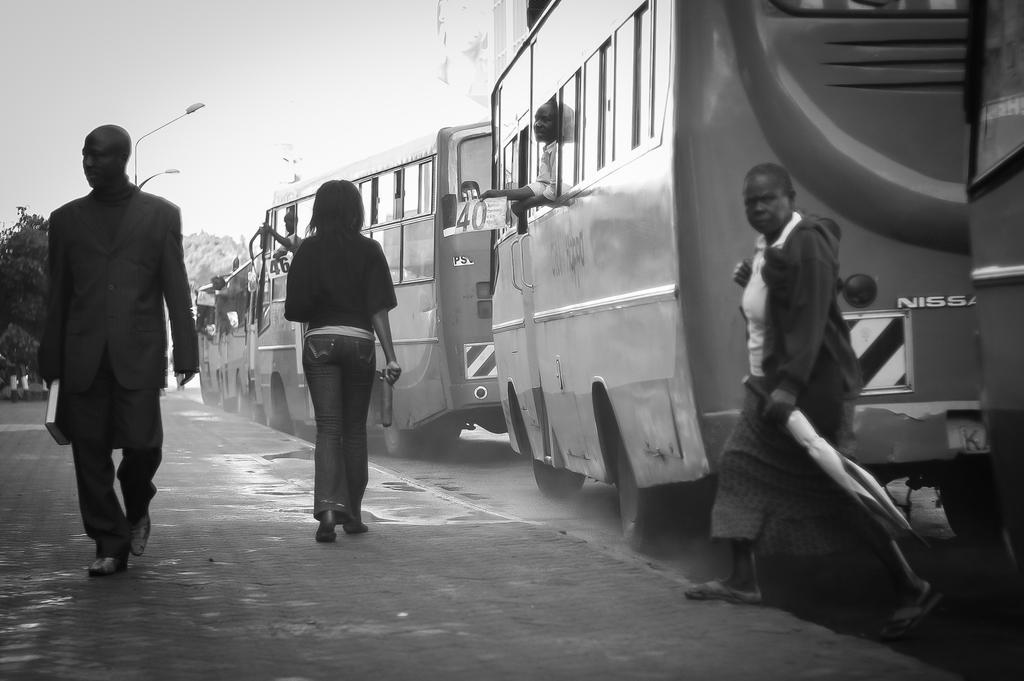Can you describe this image briefly? It looks like a black and white image. I can see three people standing. I think these are the buses on the road. On the left side of the image, that looks like a tree and the street lights. I can see few people in the buses. 